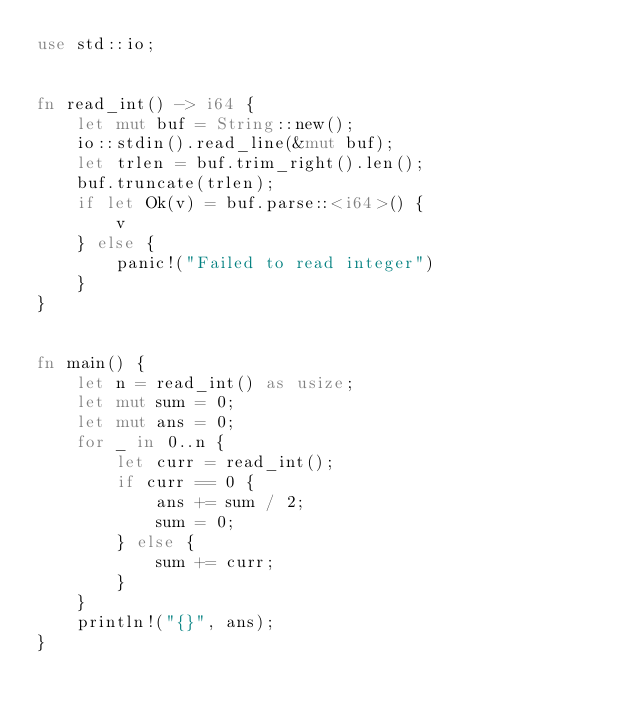<code> <loc_0><loc_0><loc_500><loc_500><_Rust_>use std::io;


fn read_int() -> i64 {
    let mut buf = String::new();
    io::stdin().read_line(&mut buf);
    let trlen = buf.trim_right().len();
    buf.truncate(trlen);
    if let Ok(v) = buf.parse::<i64>() {
        v
    } else {
        panic!("Failed to read integer")
    }
}


fn main() {
    let n = read_int() as usize;
    let mut sum = 0;
    let mut ans = 0;
    for _ in 0..n {
        let curr = read_int();
        if curr == 0 {
            ans += sum / 2;
            sum = 0;
        } else {
            sum += curr;
        }
    }
    println!("{}", ans);
}
</code> 